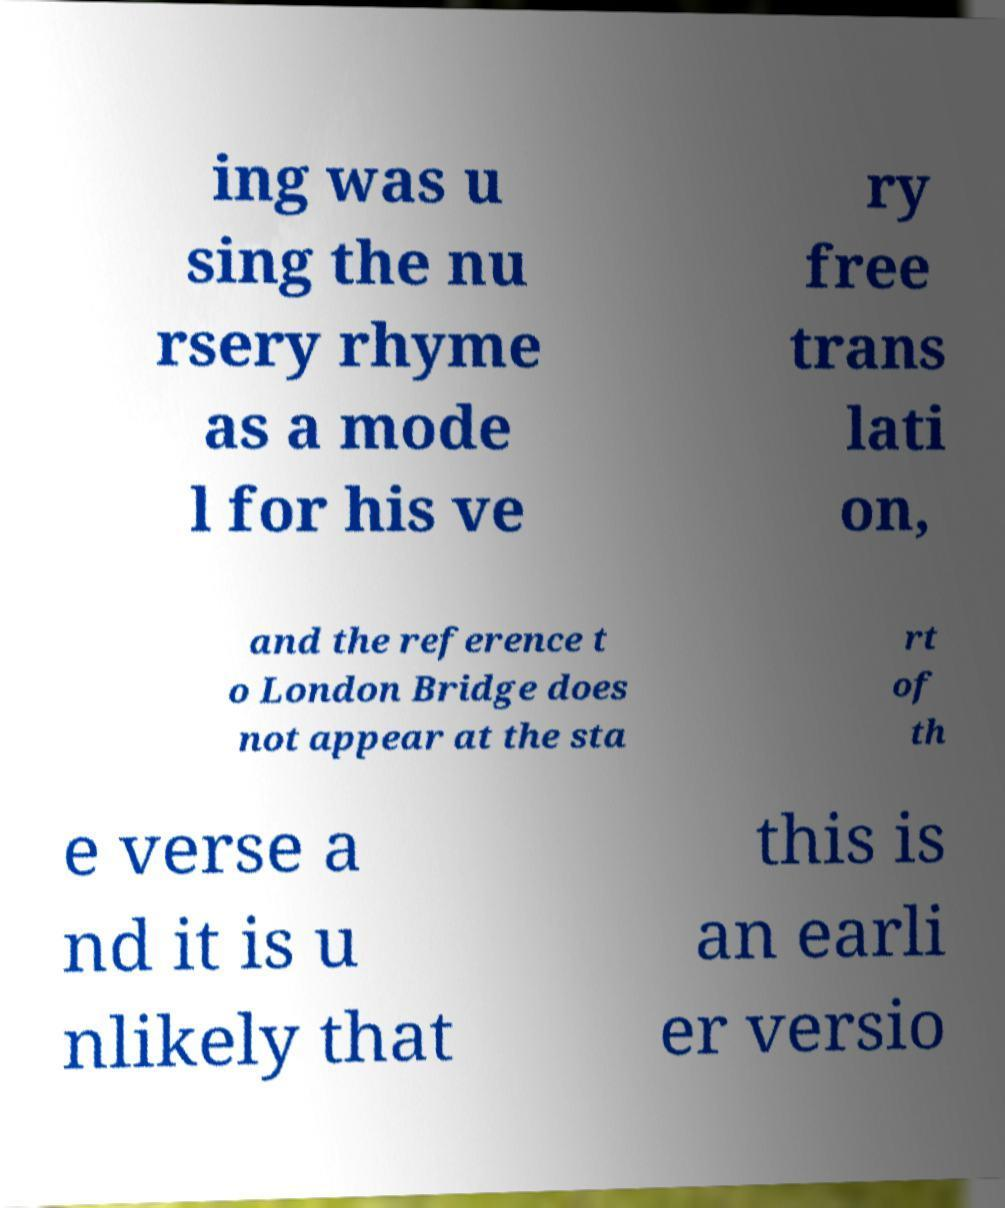Please identify and transcribe the text found in this image. ing was u sing the nu rsery rhyme as a mode l for his ve ry free trans lati on, and the reference t o London Bridge does not appear at the sta rt of th e verse a nd it is u nlikely that this is an earli er versio 